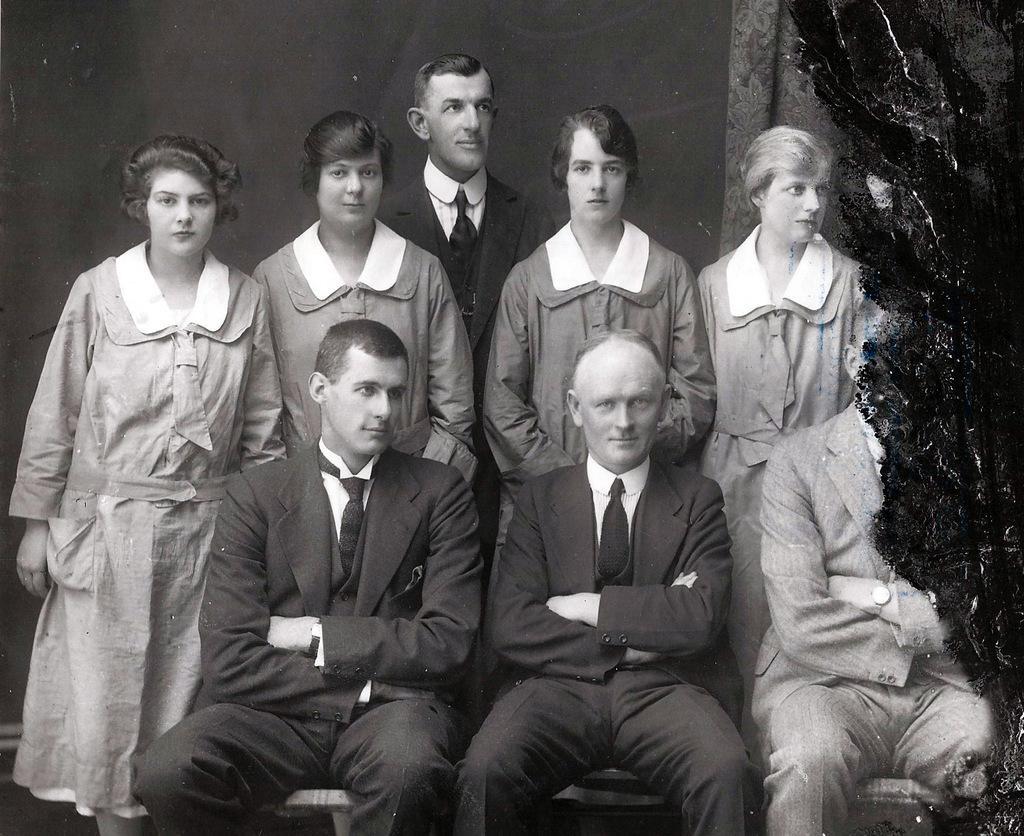Can you describe this image briefly? This image is a photograph. In the center of the image there are people standing and some of them are sitting. 